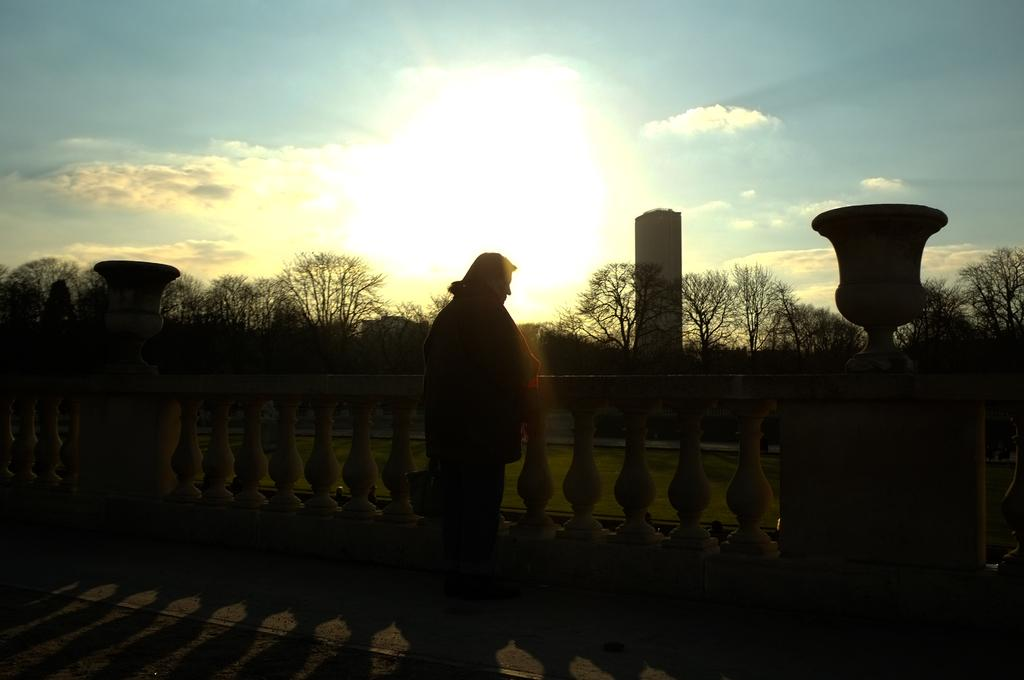Who or what is the main subject in the center of the image? There is a person in the center of the image. What can be seen in the distance behind the person? There are trees and a building in the background of the image. What artistic elements are present in the image? Sculptures are present in the image. What architectural feature is at the bottom of the image? There is a wall at the bottom of the image. What type of jam is being served on the cushion in the image? There is no jam or cushion present in the image. What language is the person speaking in the image? The image does not provide any information about the person's speech or language. 